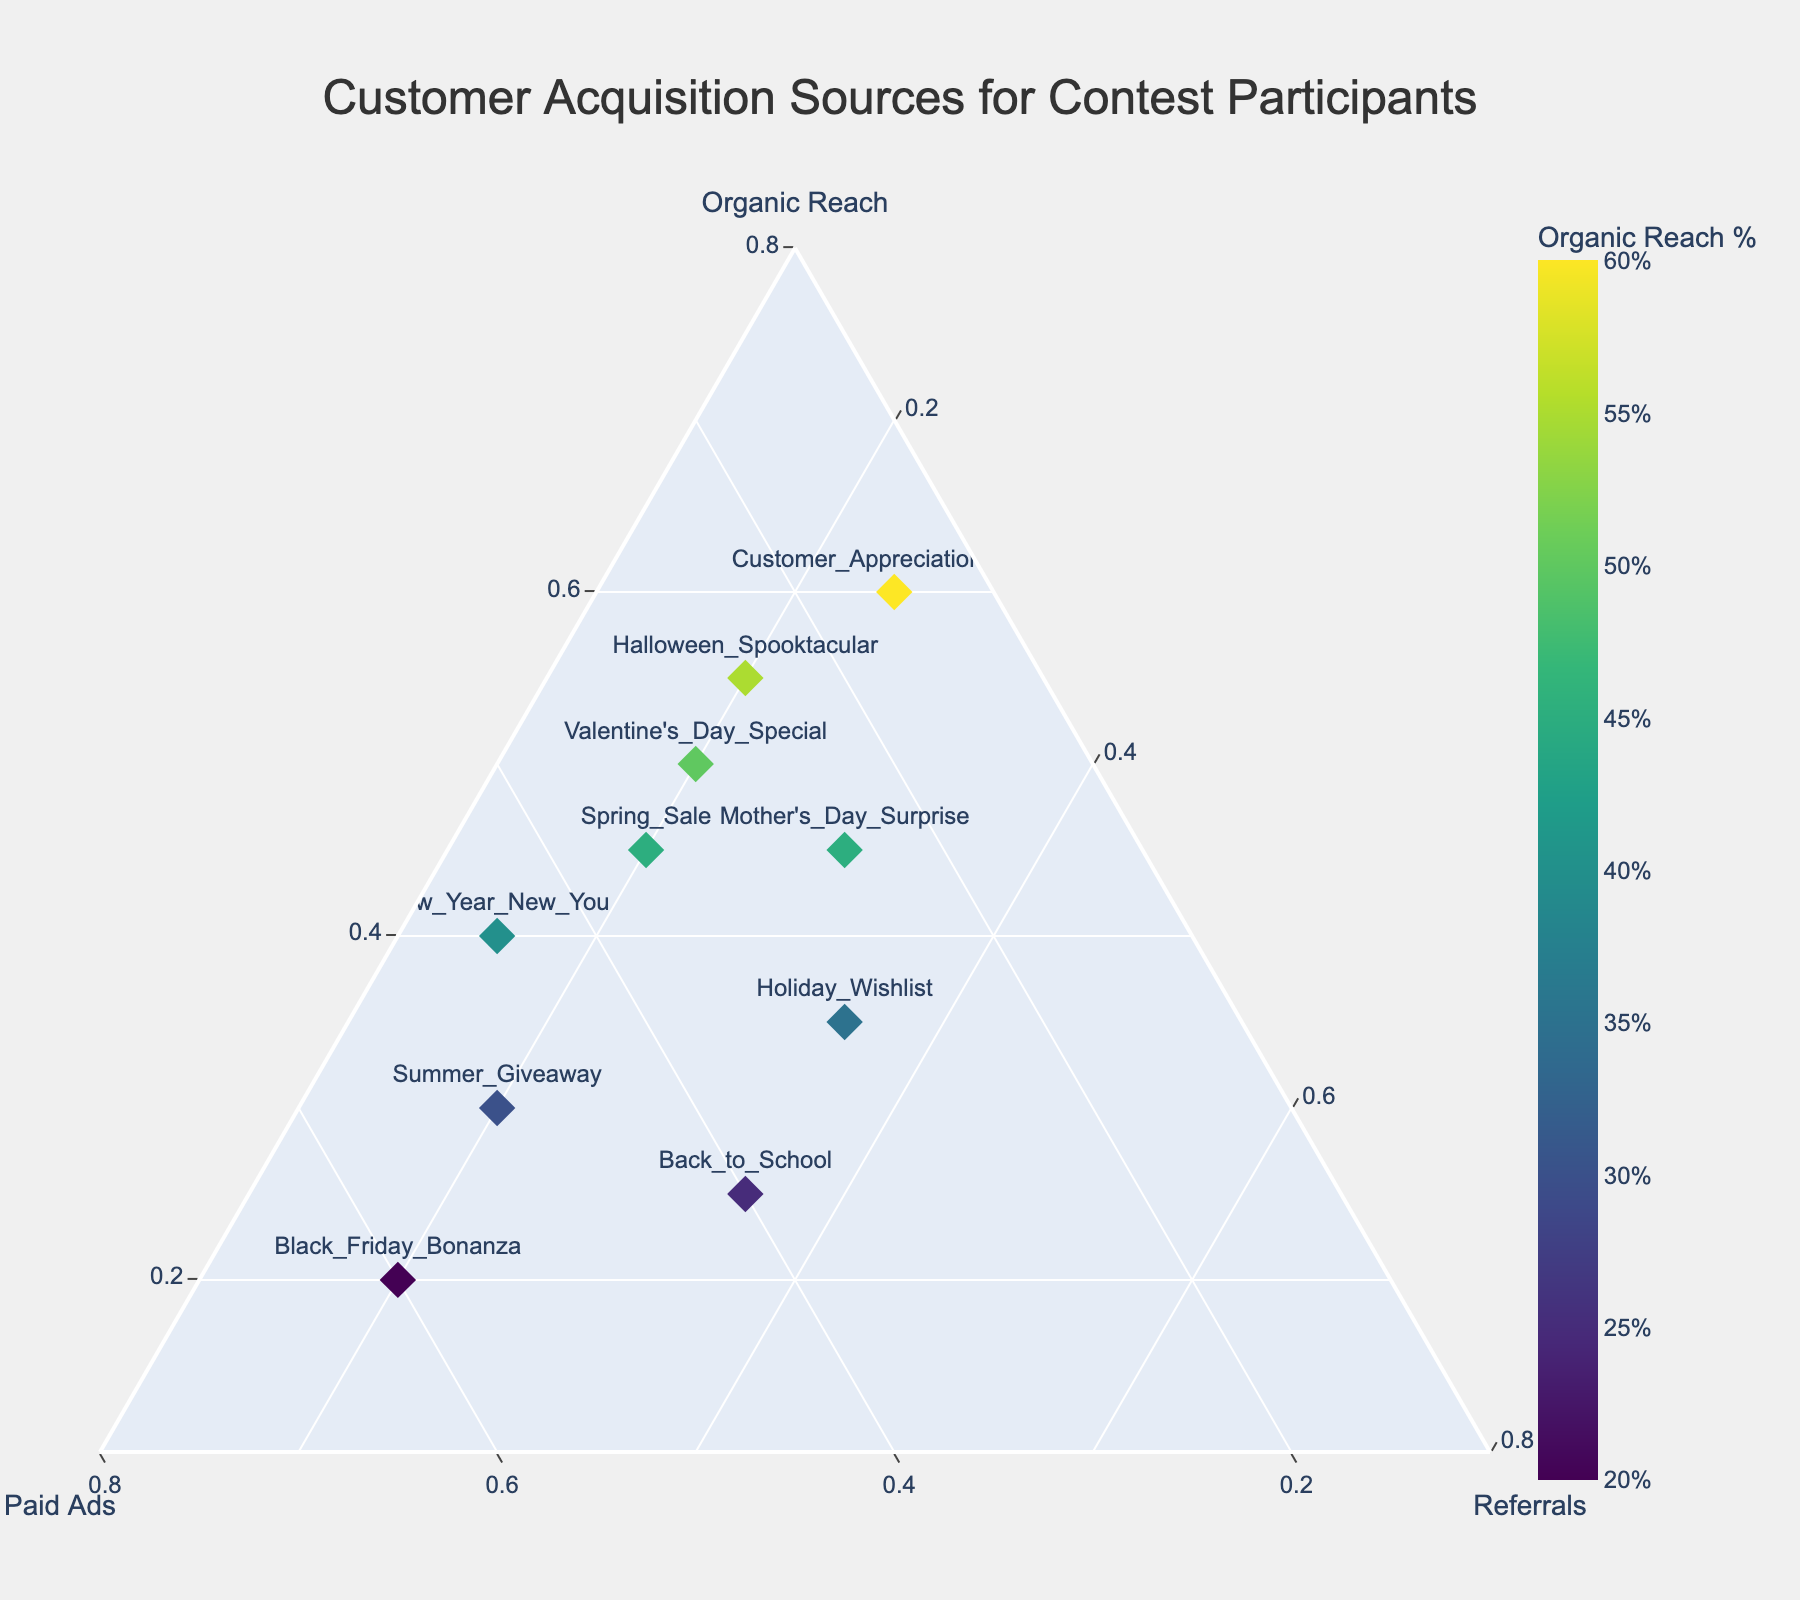Which contest has the highest representation from Organic Reach? By examining the plot, the contest closest to the Organic Reach axis extremity (close to 1, or 100%) represents the highest value.
Answer: Customer Appreciation Week Which contest has the highest representation from Paid Ads? By scanning the plot, look for the contest near the Paid Ads axis extremity (close to 1, or 100%).
Answer: Black Friday Bonanza Which contest has the highest percentage of Referrals? Locate the contest positioned closest to the Referrals axis extremity on the plot.
Answer: Back to School Is there a contest with equal representation from two sources? By reviewing the plot, find any point aligning evenly between two axes, or check the hover text for percentages that match.
Answer: Holiday Wishlist Which contests have more than 50% combined representation from Organic Reach and Referrals? Search for contests where the sum of Organic Reach and Referrals (the areas close to the top and right side of the triangle, respectively) is over 0.50.
Answer: Back to School, Holiday Wishlist, Mother's Day Surprise Compare Organic Reach between "New Year New You" and "Valentine's Day Special". Which contest has a higher percentage? Identify the positions of both contests on the plot and check the Organic Reach axis to see which is higher.
Answer: Valentine's Day Special What is the sum of Paid Ads representation for "Spring Sale" and "Halloween Spooktacular"? Add the Paid Ads percentages of "Spring Sale" (0.35) and "Halloween Spooktacular" (0.25). 0.35 + 0.25 = 0.60 or 60%
Answer: 60% Which contest has the lowest percentage from Referrals? Locate the contest positioned closest to the bottom part of the plot along the Referrals axis.
Answer: New Year New You Between "Mother's Day Surprise" and "Summer Giveaway", which contest has a more balanced distribution and why? Examine both positions and their hover text on the plot to compare how even their percentages are split among the three sources. "Mother's Day Surprise" has a more balanced spread (0.45, 0.25, 0.30) compared to "Summer Giveaway" (0.30, 0.50, 0.20) which leans towards Paid Ads.
Answer: Mother's Day Surprise 